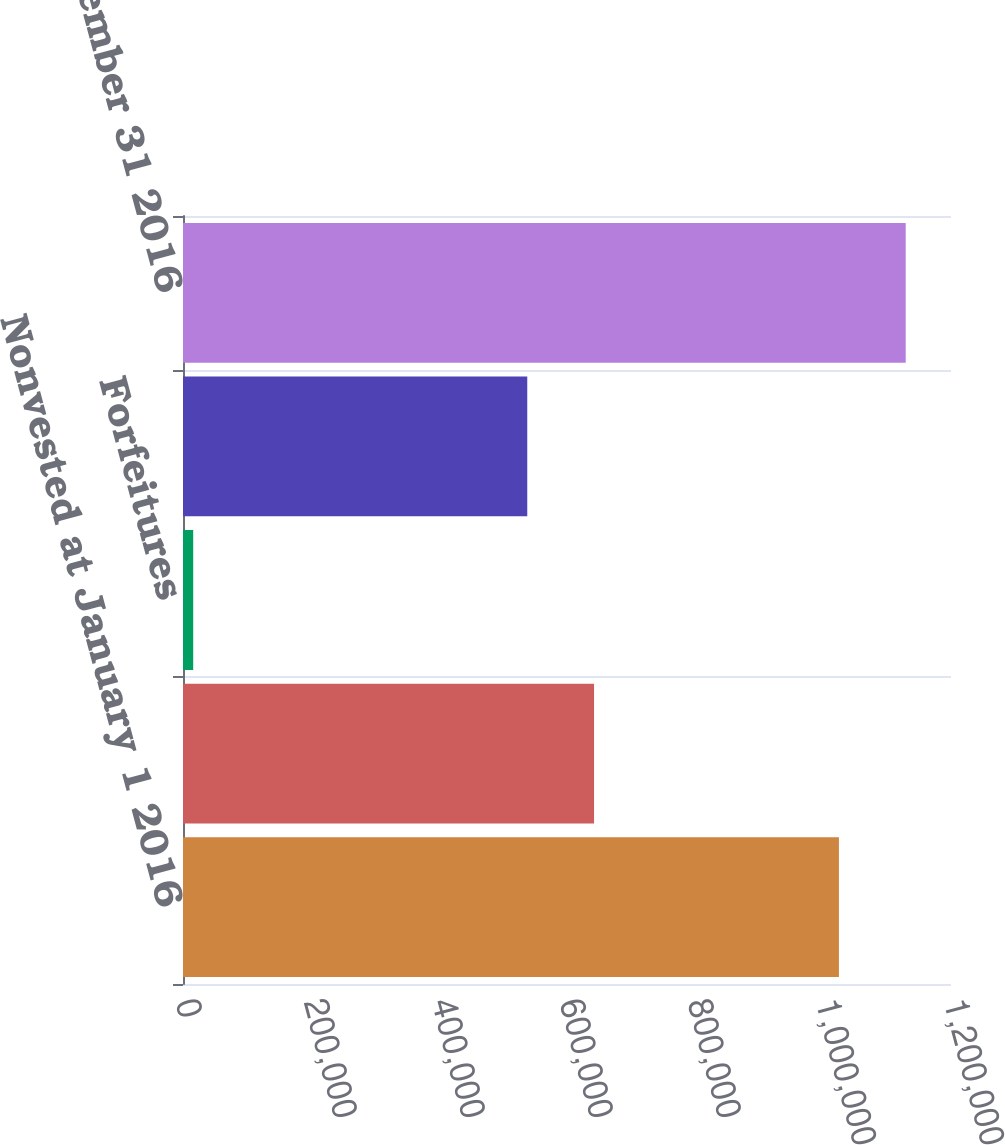Convert chart to OTSL. <chart><loc_0><loc_0><loc_500><loc_500><bar_chart><fcel>Nonvested at January 1 2016<fcel>Granted (a)<fcel>Forfeitures<fcel>Earned and vested (b)<fcel>Nonvested at December 31 2016<nl><fcel>1.02487e+06<fcel>642266<fcel>15949<fcel>537897<fcel>1.12924e+06<nl></chart> 